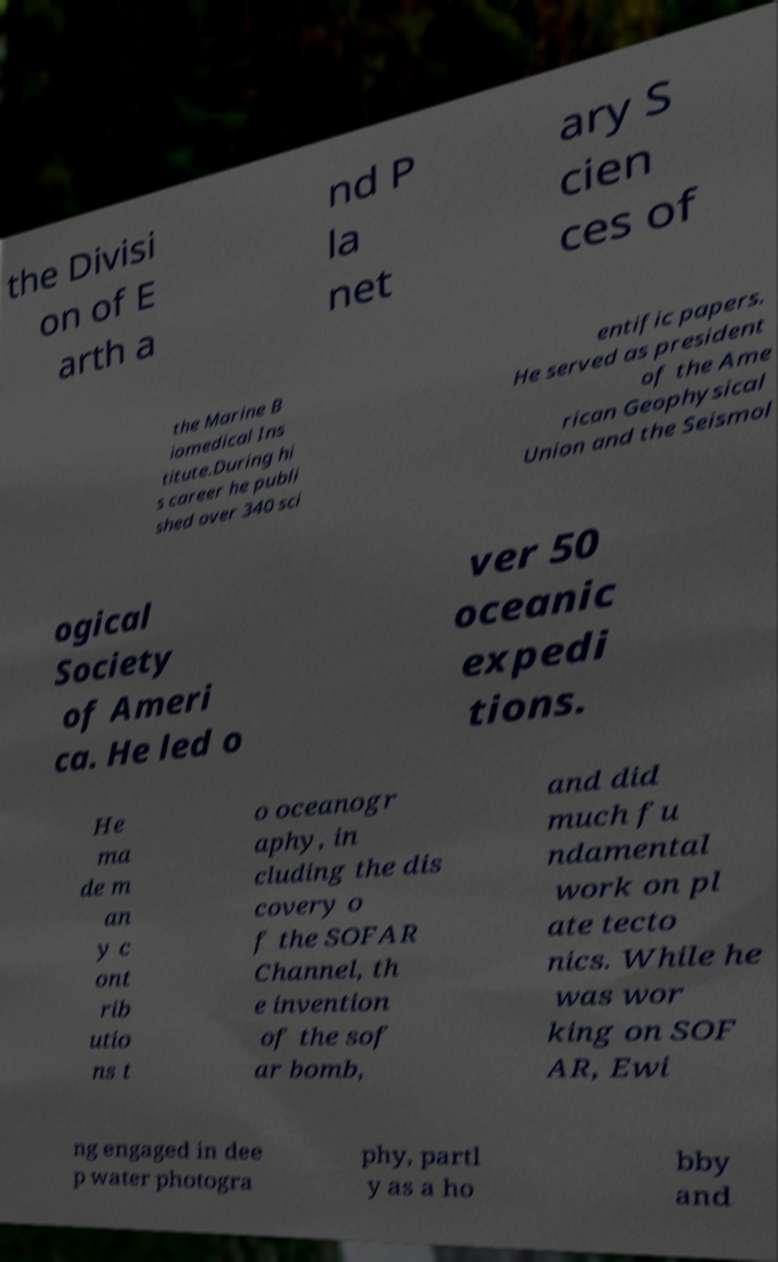Could you extract and type out the text from this image? the Divisi on of E arth a nd P la net ary S cien ces of the Marine B iomedical Ins titute.During hi s career he publi shed over 340 sci entific papers. He served as president of the Ame rican Geophysical Union and the Seismol ogical Society of Ameri ca. He led o ver 50 oceanic expedi tions. He ma de m an y c ont rib utio ns t o oceanogr aphy, in cluding the dis covery o f the SOFAR Channel, th e invention of the sof ar bomb, and did much fu ndamental work on pl ate tecto nics. While he was wor king on SOF AR, Ewi ng engaged in dee p water photogra phy, partl y as a ho bby and 